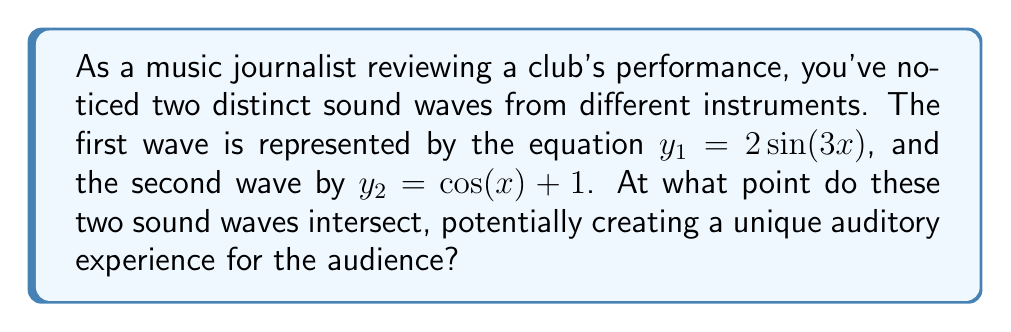Can you solve this math problem? To find the intersection point of these two sound waves, we need to solve the equation:

$$2\sin(3x) = \cos(x) + 1$$

Let's approach this step-by-step:

1) First, let's isolate the trigonometric functions on one side:

   $$2\sin(3x) - \cos(x) = 1$$

2) This equation is difficult to solve analytically due to the different frequencies. We can use a graphical or numerical method to approximate the solution.

3) Using a graphing calculator or computer software, we can plot both functions:

   $$y = 2\sin(3x)$$
   $$y = \cos(x) + 1$$

4) Visually, we can see that the first intersection point occurs between $x = 0$ and $x = \frac{\pi}{2}$.

5) Using a numerical method like Newton-Raphson or bisection, we can find that the intersection occurs approximately at:

   $$x \approx 0.4836$$

6) To find the y-coordinate, we can plug this x-value into either of the original equations. Let's use the first one:

   $$y = 2\sin(3(0.4836)) \approx 1.4686$$

Therefore, the waves intersect at approximately the point (0.4836, 1.4686).
Answer: (0.4836, 1.4686) 